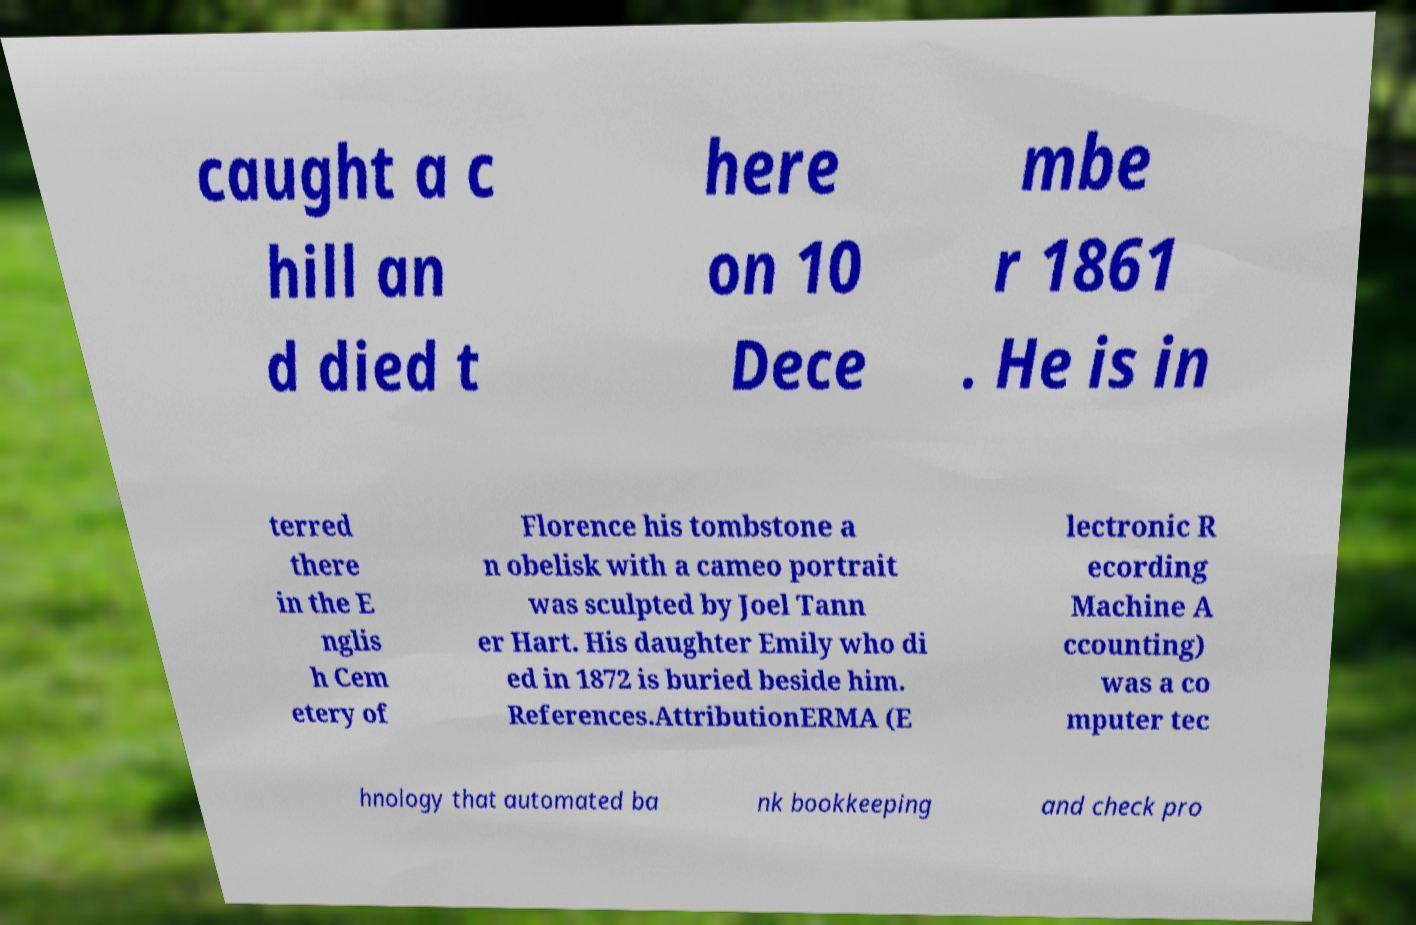Could you extract and type out the text from this image? caught a c hill an d died t here on 10 Dece mbe r 1861 . He is in terred there in the E nglis h Cem etery of Florence his tombstone a n obelisk with a cameo portrait was sculpted by Joel Tann er Hart. His daughter Emily who di ed in 1872 is buried beside him. References.AttributionERMA (E lectronic R ecording Machine A ccounting) was a co mputer tec hnology that automated ba nk bookkeeping and check pro 